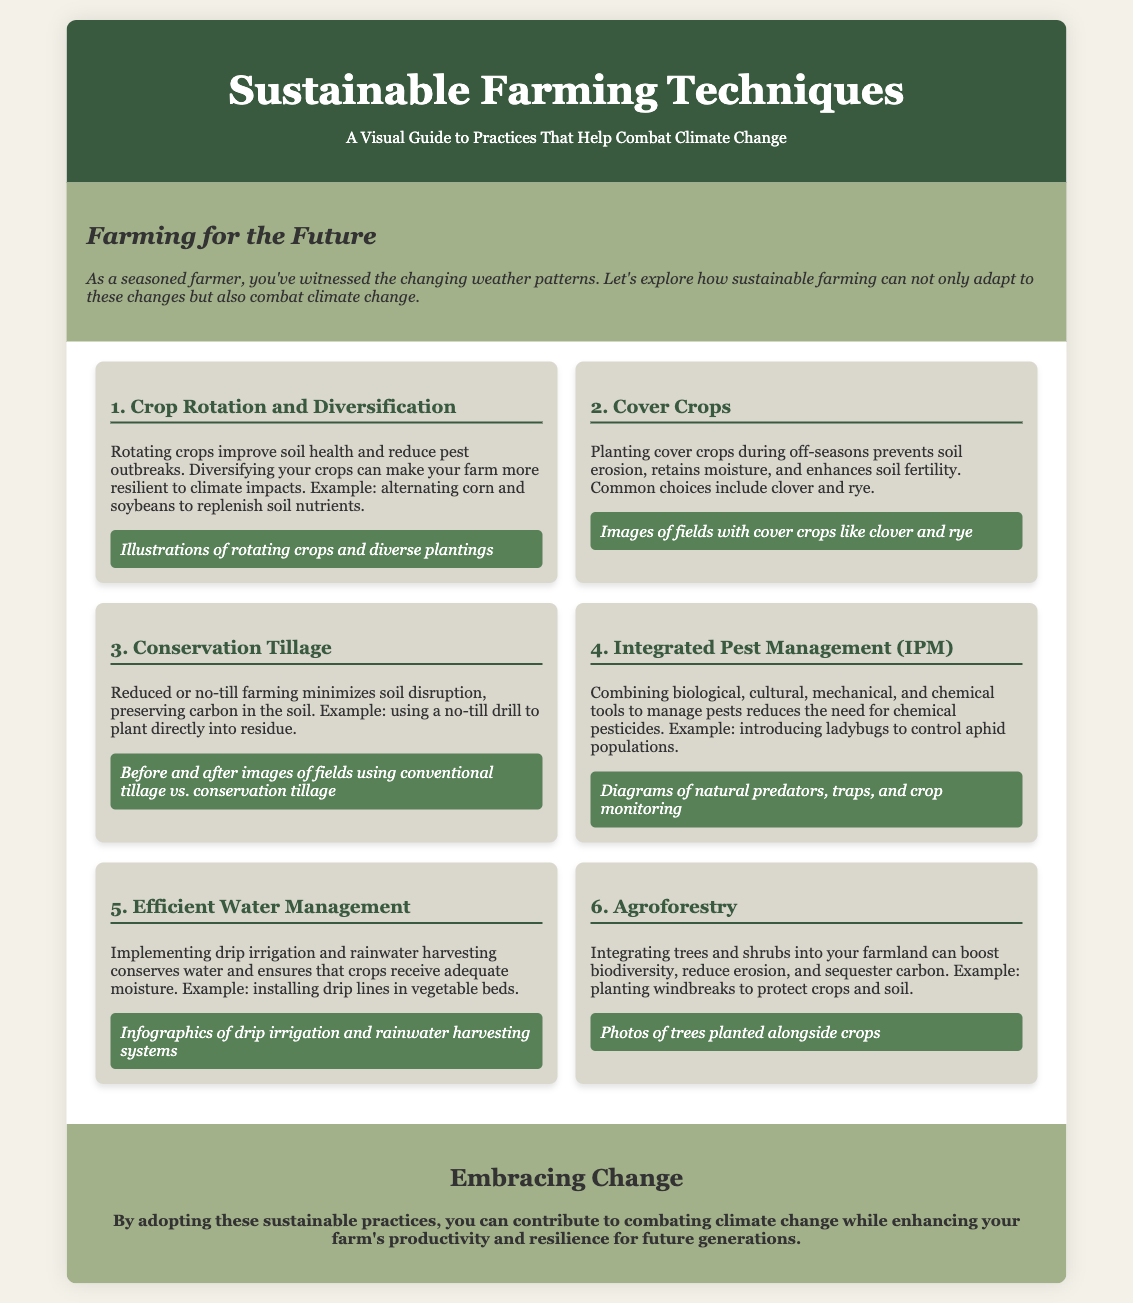what is the first sustainable farming technique mentioned? The first sustainable farming technique listed in the document is "Crop Rotation and Diversification."
Answer: Crop Rotation and Diversification what is one benefit of using cover crops? The document states that planting cover crops prevents soil erosion.
Answer: Prevents soil erosion which farming practice minimizes soil disruption? The practice that minimizes soil disruption is called "Conservation Tillage."
Answer: Conservation Tillage what is an example of Integrated Pest Management mentioned? The document provides the example of introducing ladybugs to control aphid populations as a method of IPM.
Answer: Introducing ladybugs how does efficient water management help farming? Efficient water management conserves water and ensures crops receive adequate moisture.
Answer: Conserves water what are two types of cover crops mentioned? The document lists clover and rye as common choices for cover crops.
Answer: Clover and rye which sustainable farming technique combines trees with crops? The sustainable farming technique that combines trees and crops is called "Agroforestry."
Answer: Agroforestry what is one visual representation shown for Conservation Tillage? The document includes "Before and after images of fields using conventional tillage vs. conservation tillage."
Answer: Before and after images what overall goal do the sustainable practices aim to achieve? The sustainable practices aim to contribute to combating climate change while enhancing farm productivity.
Answer: Combating climate change 